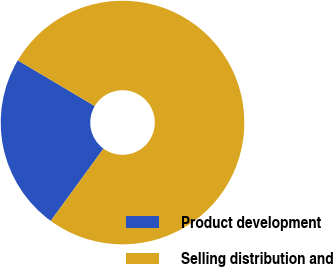<chart> <loc_0><loc_0><loc_500><loc_500><pie_chart><fcel>Product development<fcel>Selling distribution and<nl><fcel>23.5%<fcel>76.5%<nl></chart> 